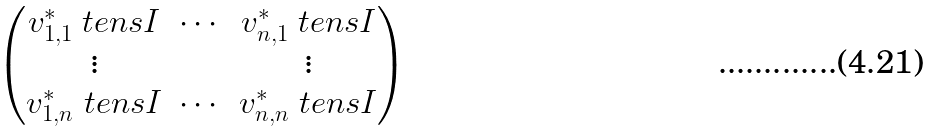Convert formula to latex. <formula><loc_0><loc_0><loc_500><loc_500>\begin{pmatrix} { v _ { 1 , 1 } ^ { * } } \ t e n s { I } & \cdots & { v _ { n , 1 } ^ { * } } \ t e n s { I } \\ \vdots & & \vdots \\ { v _ { 1 , n } ^ { * } } \ t e n s { I } & \cdots & { v _ { n , n } ^ { * } } \ t e n s { I } \\ \end{pmatrix}</formula> 